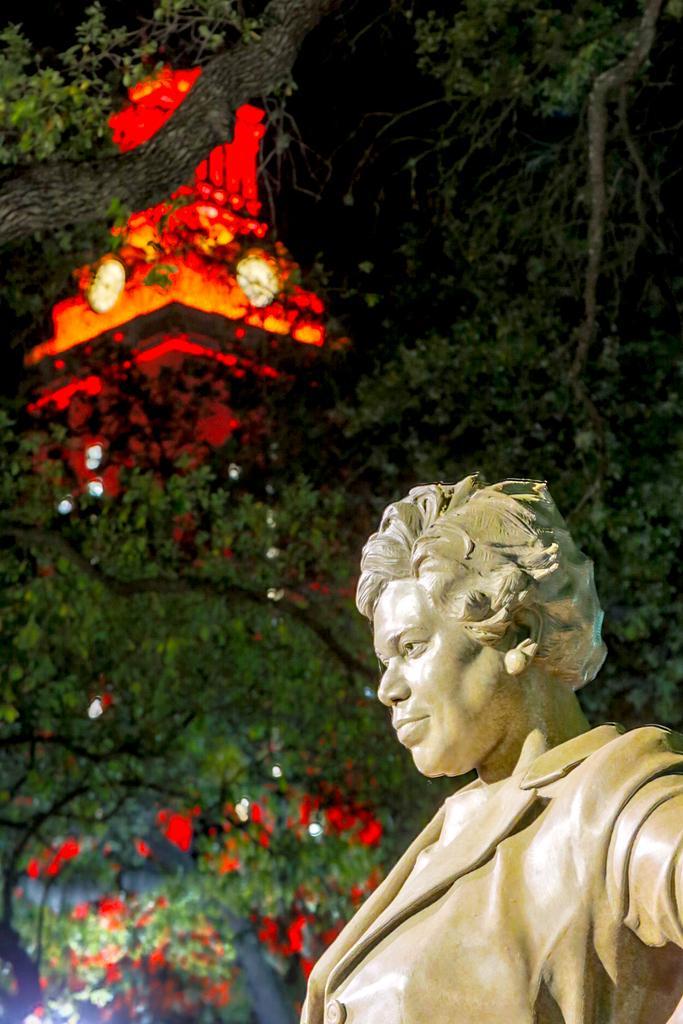Please provide a concise description of this image. On the right side of the image we can see a statue. In the background of the image we can see the trees, lights and the clock tower. At the top of the image we can see the sky. 